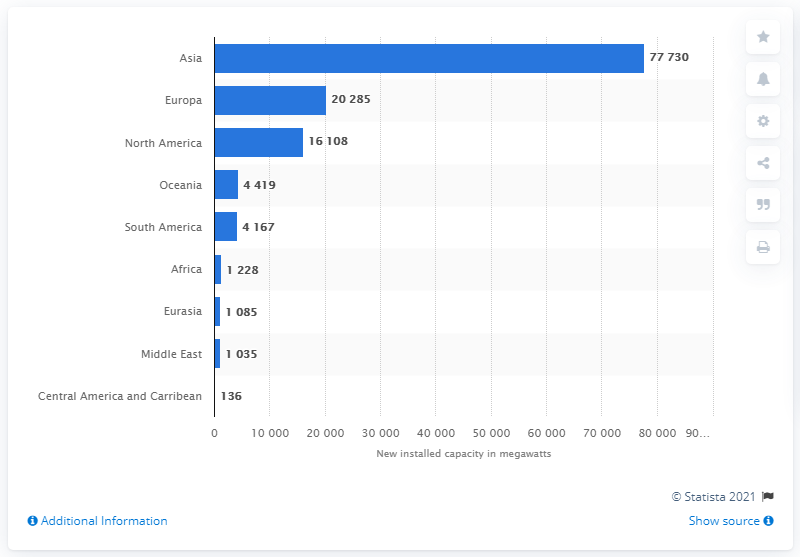Specify some key components in this picture. The country with the highest installed solar PV capacity globally is Asia. 